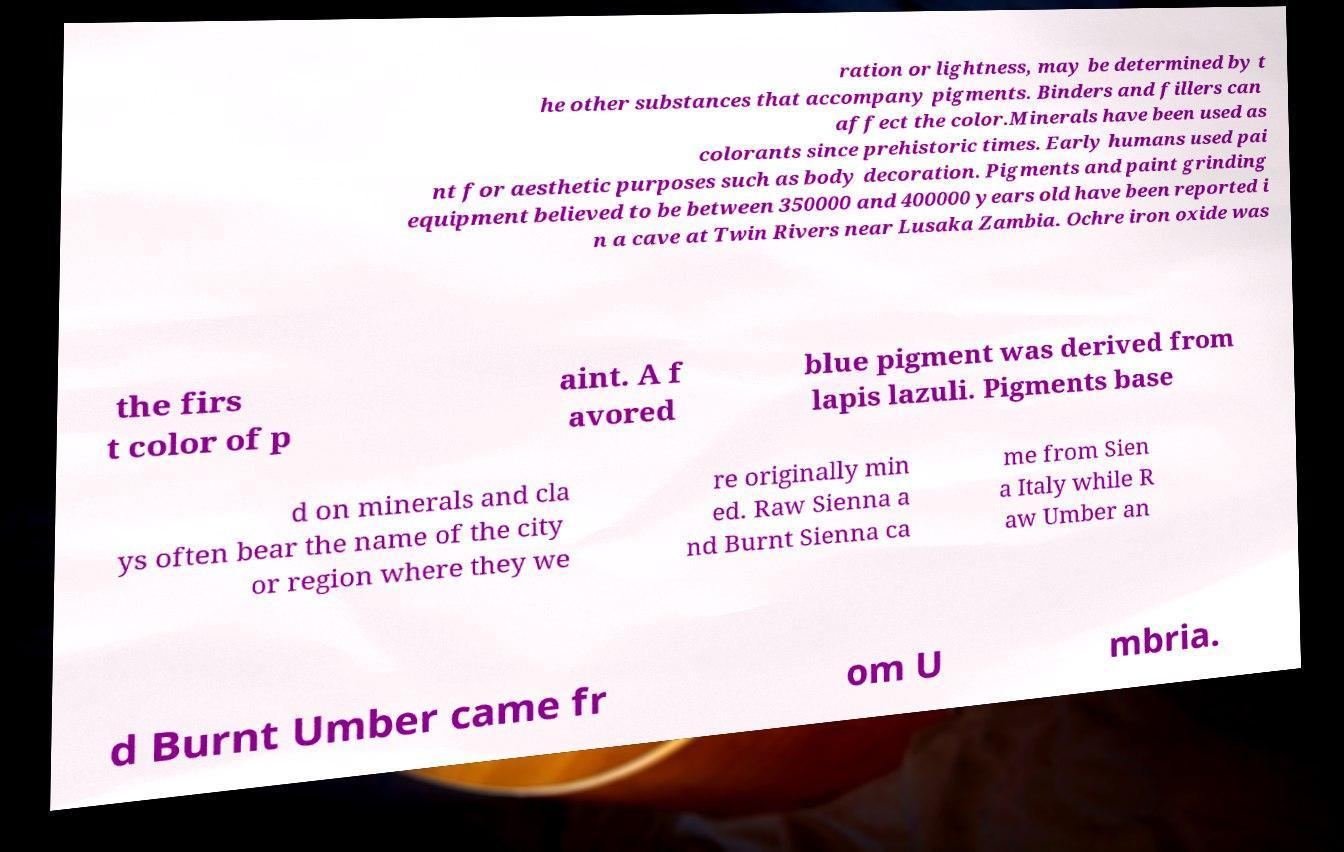Please identify and transcribe the text found in this image. ration or lightness, may be determined by t he other substances that accompany pigments. Binders and fillers can affect the color.Minerals have been used as colorants since prehistoric times. Early humans used pai nt for aesthetic purposes such as body decoration. Pigments and paint grinding equipment believed to be between 350000 and 400000 years old have been reported i n a cave at Twin Rivers near Lusaka Zambia. Ochre iron oxide was the firs t color of p aint. A f avored blue pigment was derived from lapis lazuli. Pigments base d on minerals and cla ys often bear the name of the city or region where they we re originally min ed. Raw Sienna a nd Burnt Sienna ca me from Sien a Italy while R aw Umber an d Burnt Umber came fr om U mbria. 